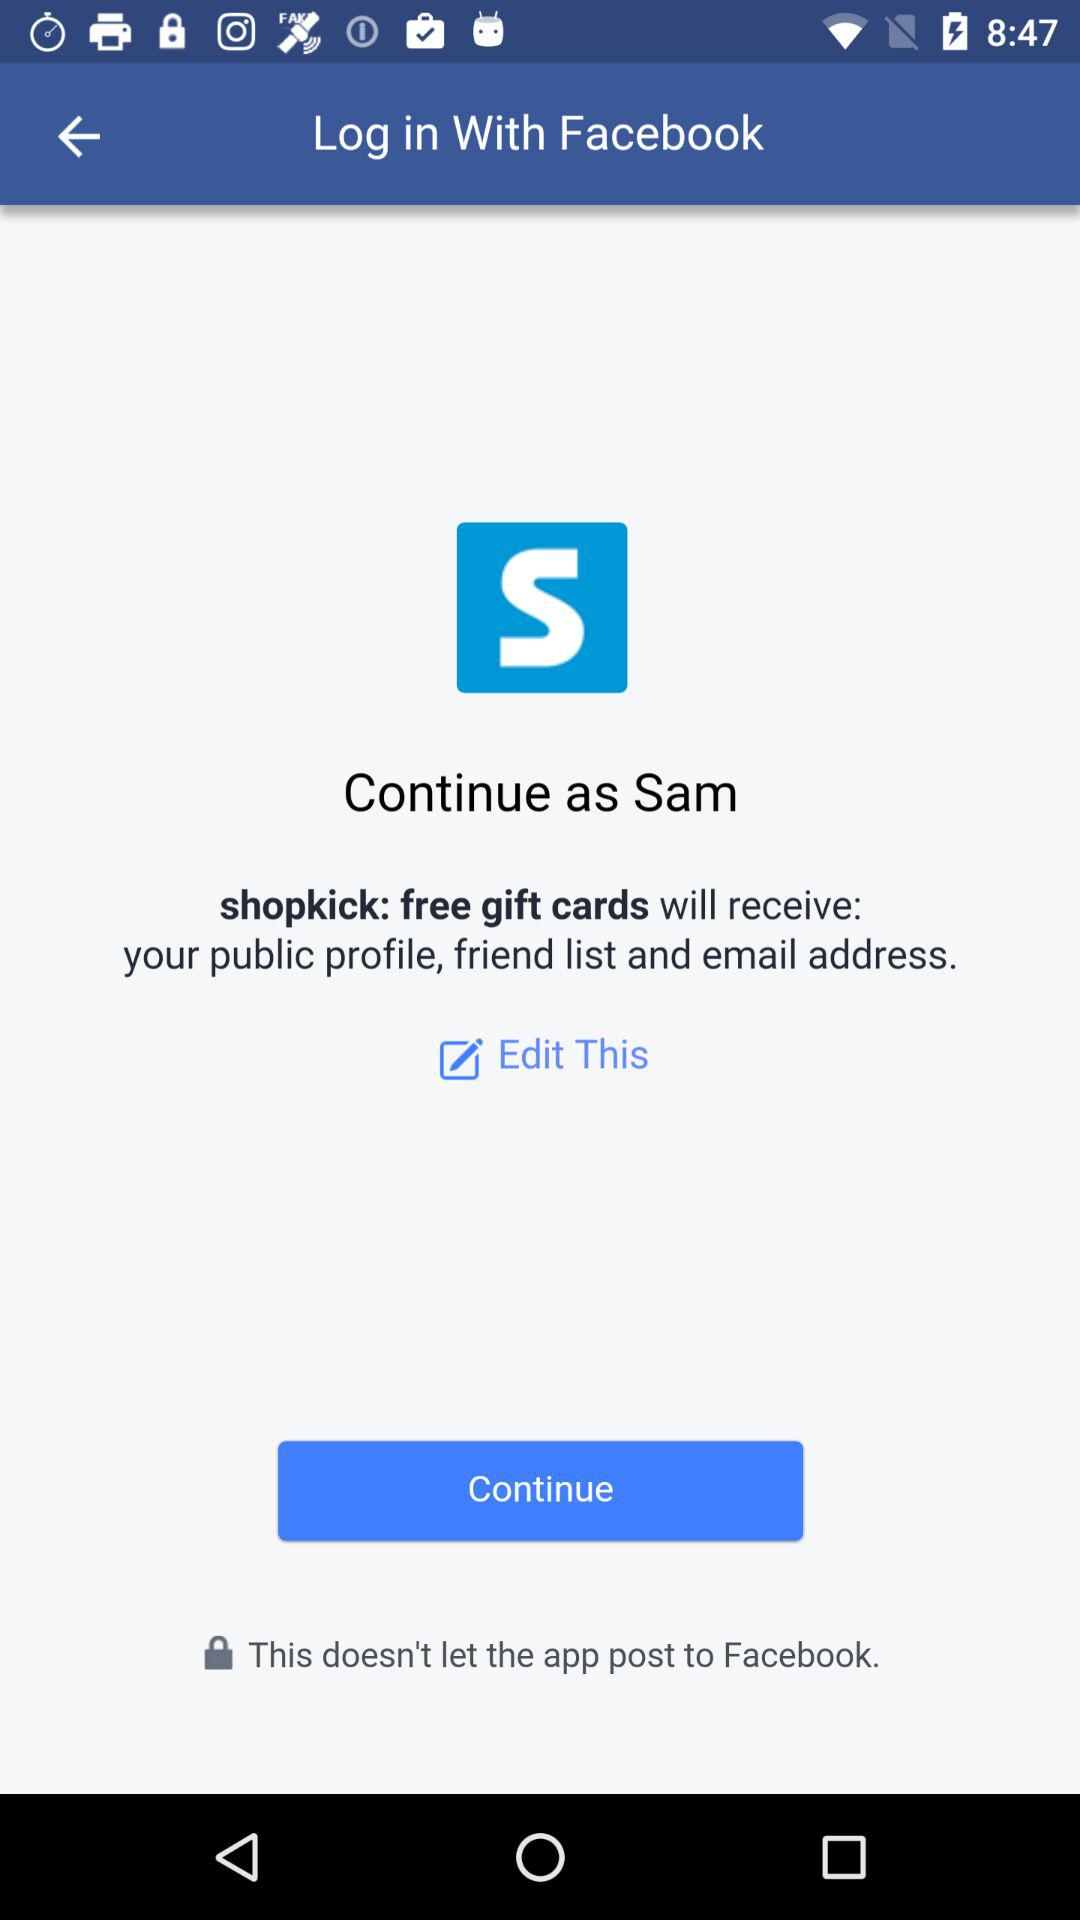Which application is asking for permission? The application asking for permission is "shopkick: free gift cards". 